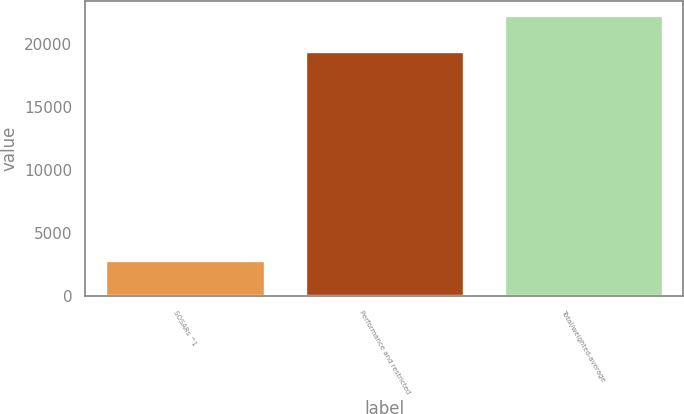<chart> <loc_0><loc_0><loc_500><loc_500><bar_chart><fcel>SOSARs ^1<fcel>Performance and restricted<fcel>Total/weighted-average<nl><fcel>2825<fcel>19498<fcel>22323<nl></chart> 